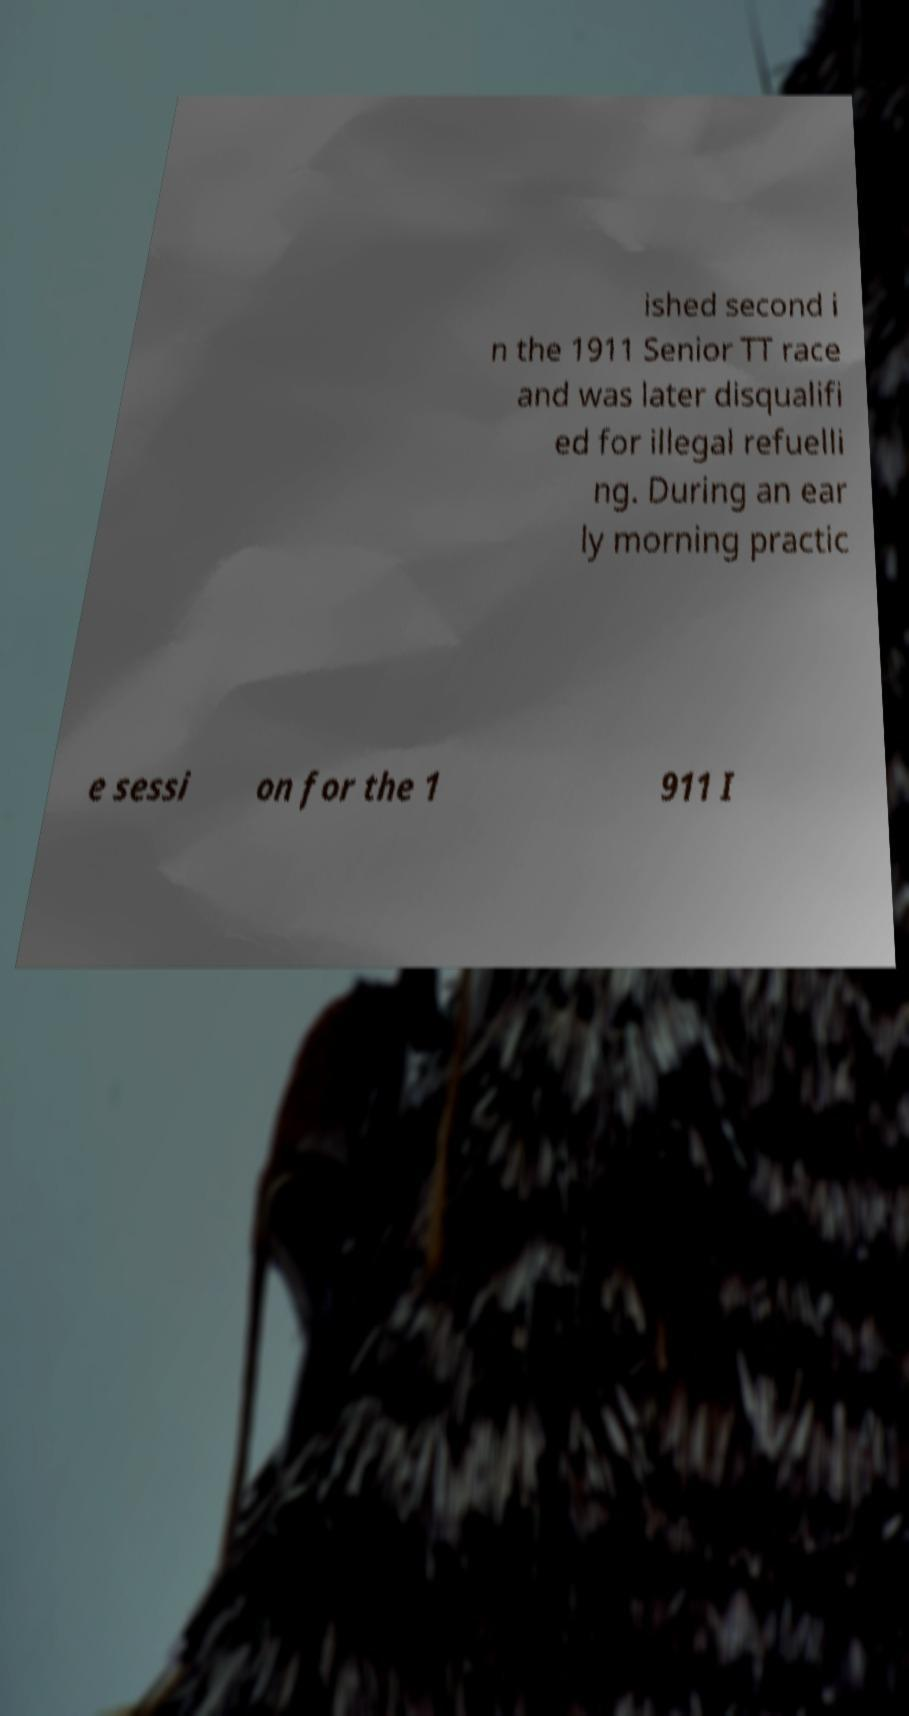For documentation purposes, I need the text within this image transcribed. Could you provide that? ished second i n the 1911 Senior TT race and was later disqualifi ed for illegal refuelli ng. During an ear ly morning practic e sessi on for the 1 911 I 